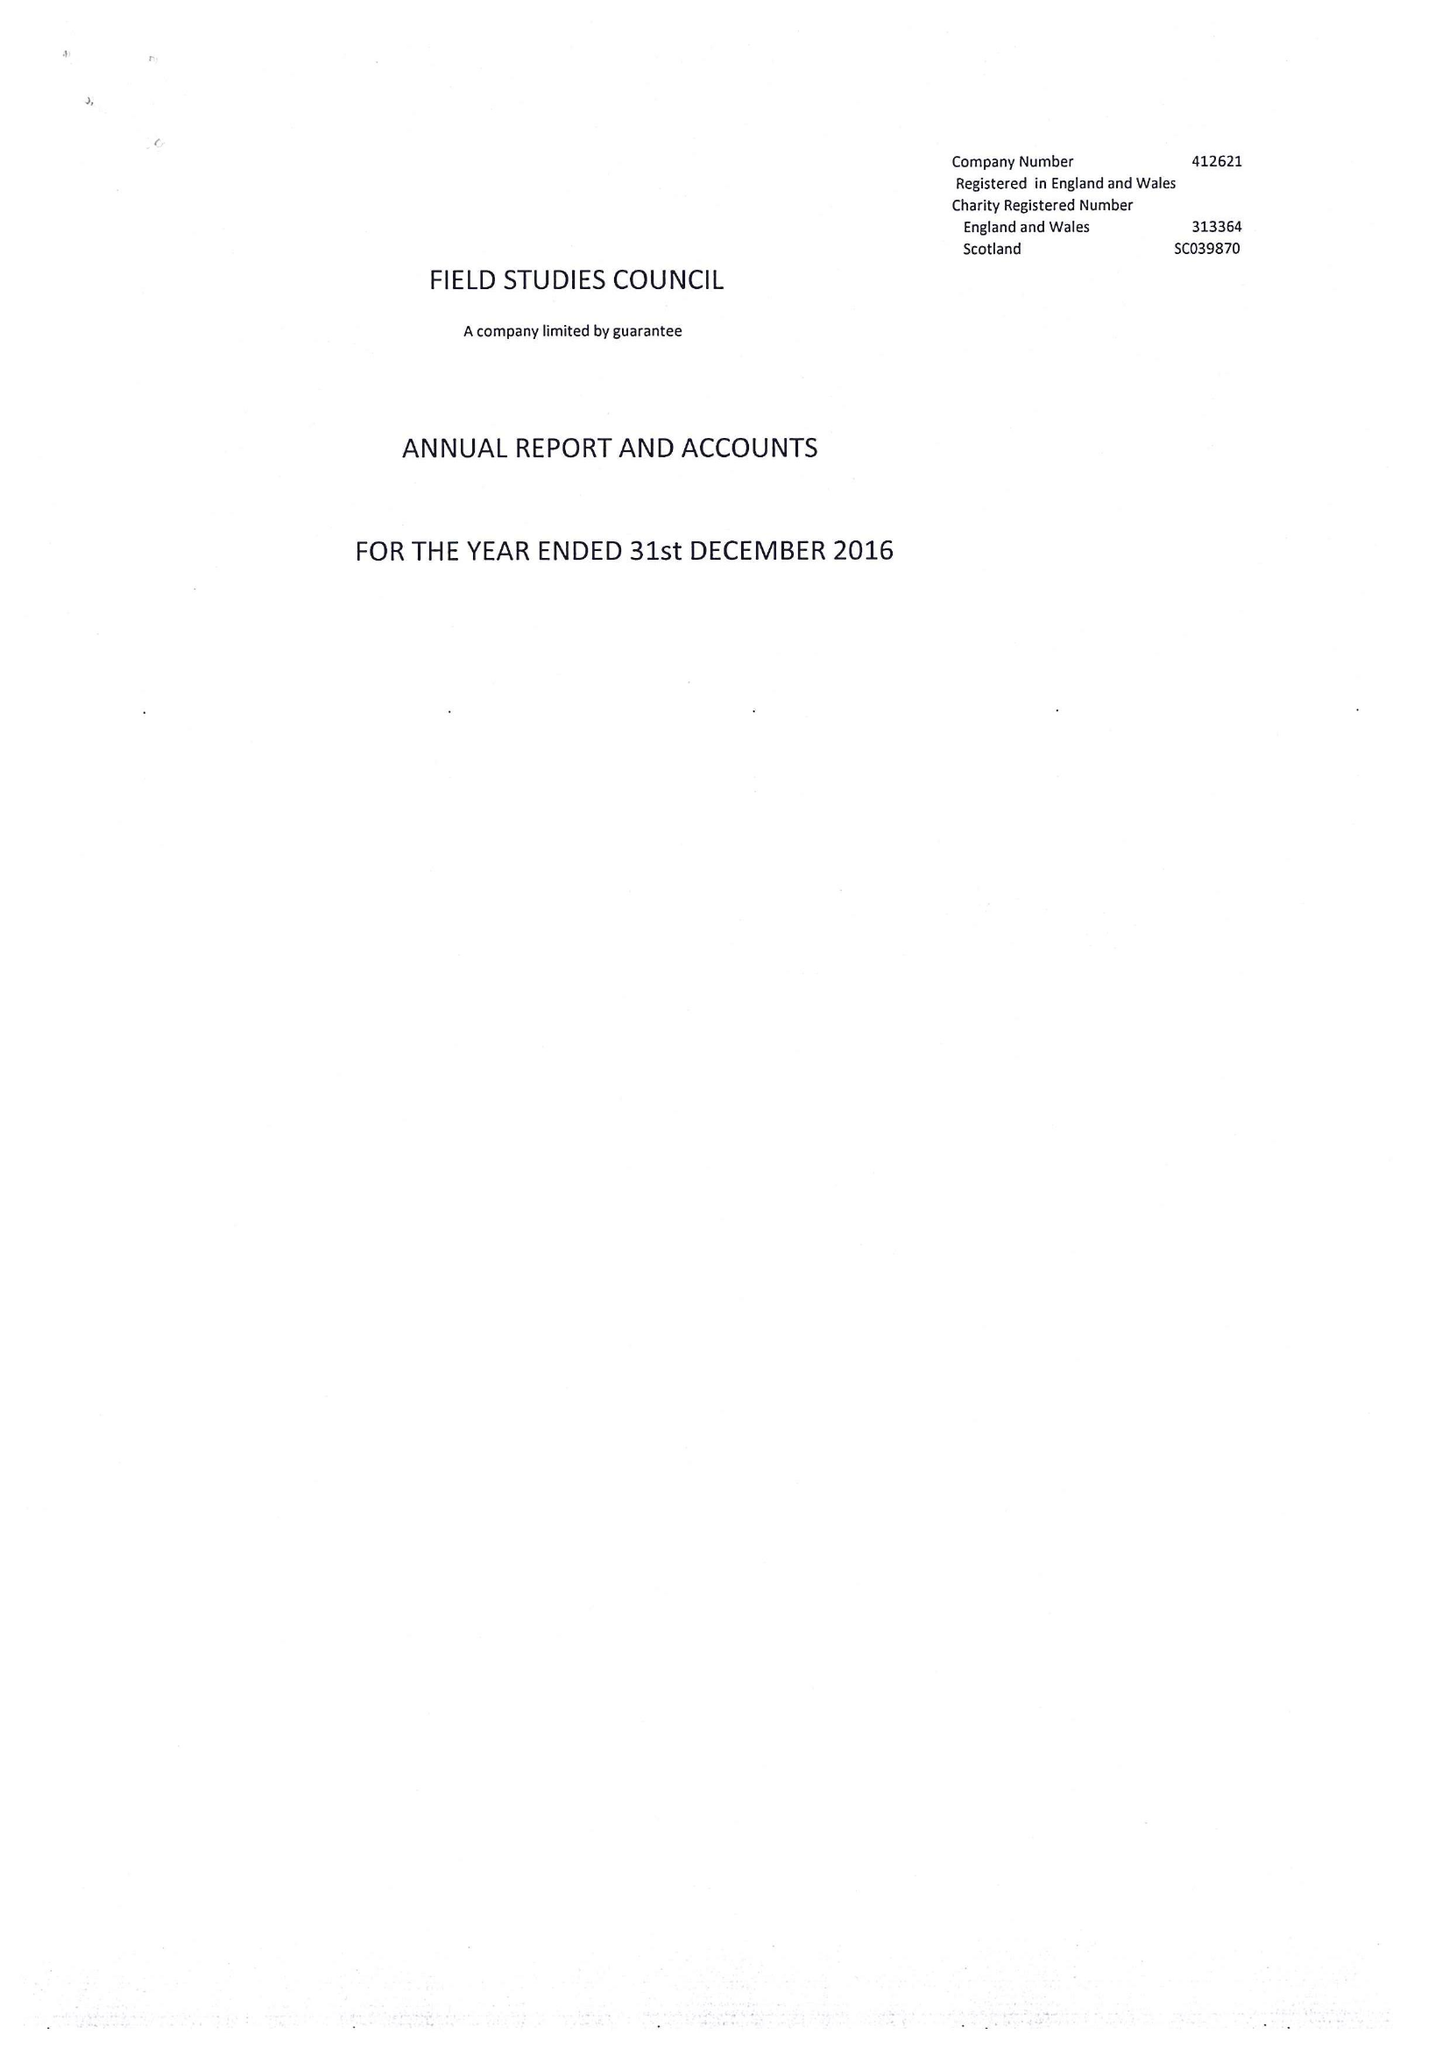What is the value for the spending_annually_in_british_pounds?
Answer the question using a single word or phrase. 16918631.00 